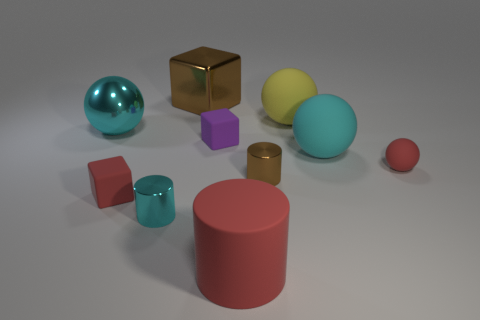Is the number of yellow matte objects less than the number of rubber spheres?
Make the answer very short. Yes. What number of objects are small green blocks or large rubber things?
Offer a terse response. 3. Is the tiny cyan object the same shape as the large red matte thing?
Your answer should be very brief. Yes. There is a cyan sphere right of the metallic sphere; is its size the same as the cyan ball that is left of the large yellow thing?
Ensure brevity in your answer.  Yes. There is a big thing that is on the right side of the large brown thing and to the left of the big yellow rubber ball; what material is it made of?
Provide a short and direct response. Rubber. Are there fewer cyan cylinders that are to the right of the big brown shiny block than big cyan matte spheres?
Ensure brevity in your answer.  Yes. Are there more large red cylinders than large cyan objects?
Your answer should be compact. No. Is there a small matte block that is right of the small cylinder left of the big red cylinder in front of the purple thing?
Provide a short and direct response. Yes. How many other things are the same size as the brown block?
Ensure brevity in your answer.  4. Are there any cyan metal things in front of the small purple block?
Ensure brevity in your answer.  Yes. 